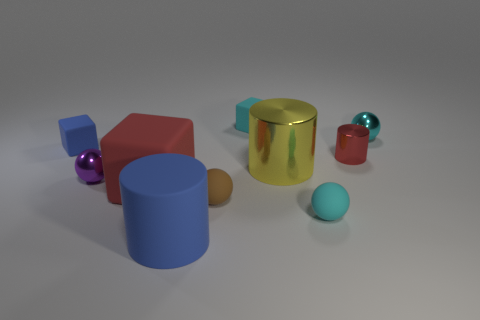Do the rubber cylinder and the small block that is in front of the small cyan block have the same color?
Provide a short and direct response. Yes. Are there any small metal objects of the same color as the big cube?
Make the answer very short. Yes. There is a big thing that is the same color as the small metallic cylinder; what is its material?
Give a very brief answer. Rubber. What size is the metal object that is the same color as the big cube?
Your response must be concise. Small. Do the big block and the tiny metal cylinder have the same color?
Your answer should be compact. Yes. How many other objects are the same shape as the big blue matte object?
Provide a succinct answer. 2. Is the number of large red matte things that are right of the yellow cylinder less than the number of tiny purple metallic things that are behind the cyan metallic sphere?
Provide a succinct answer. No. The brown thing that is the same material as the large block is what shape?
Make the answer very short. Sphere. Is there anything else of the same color as the big metal object?
Ensure brevity in your answer.  No. There is a tiny rubber sphere on the left side of the cube on the right side of the big blue rubber cylinder; what is its color?
Offer a very short reply. Brown. 